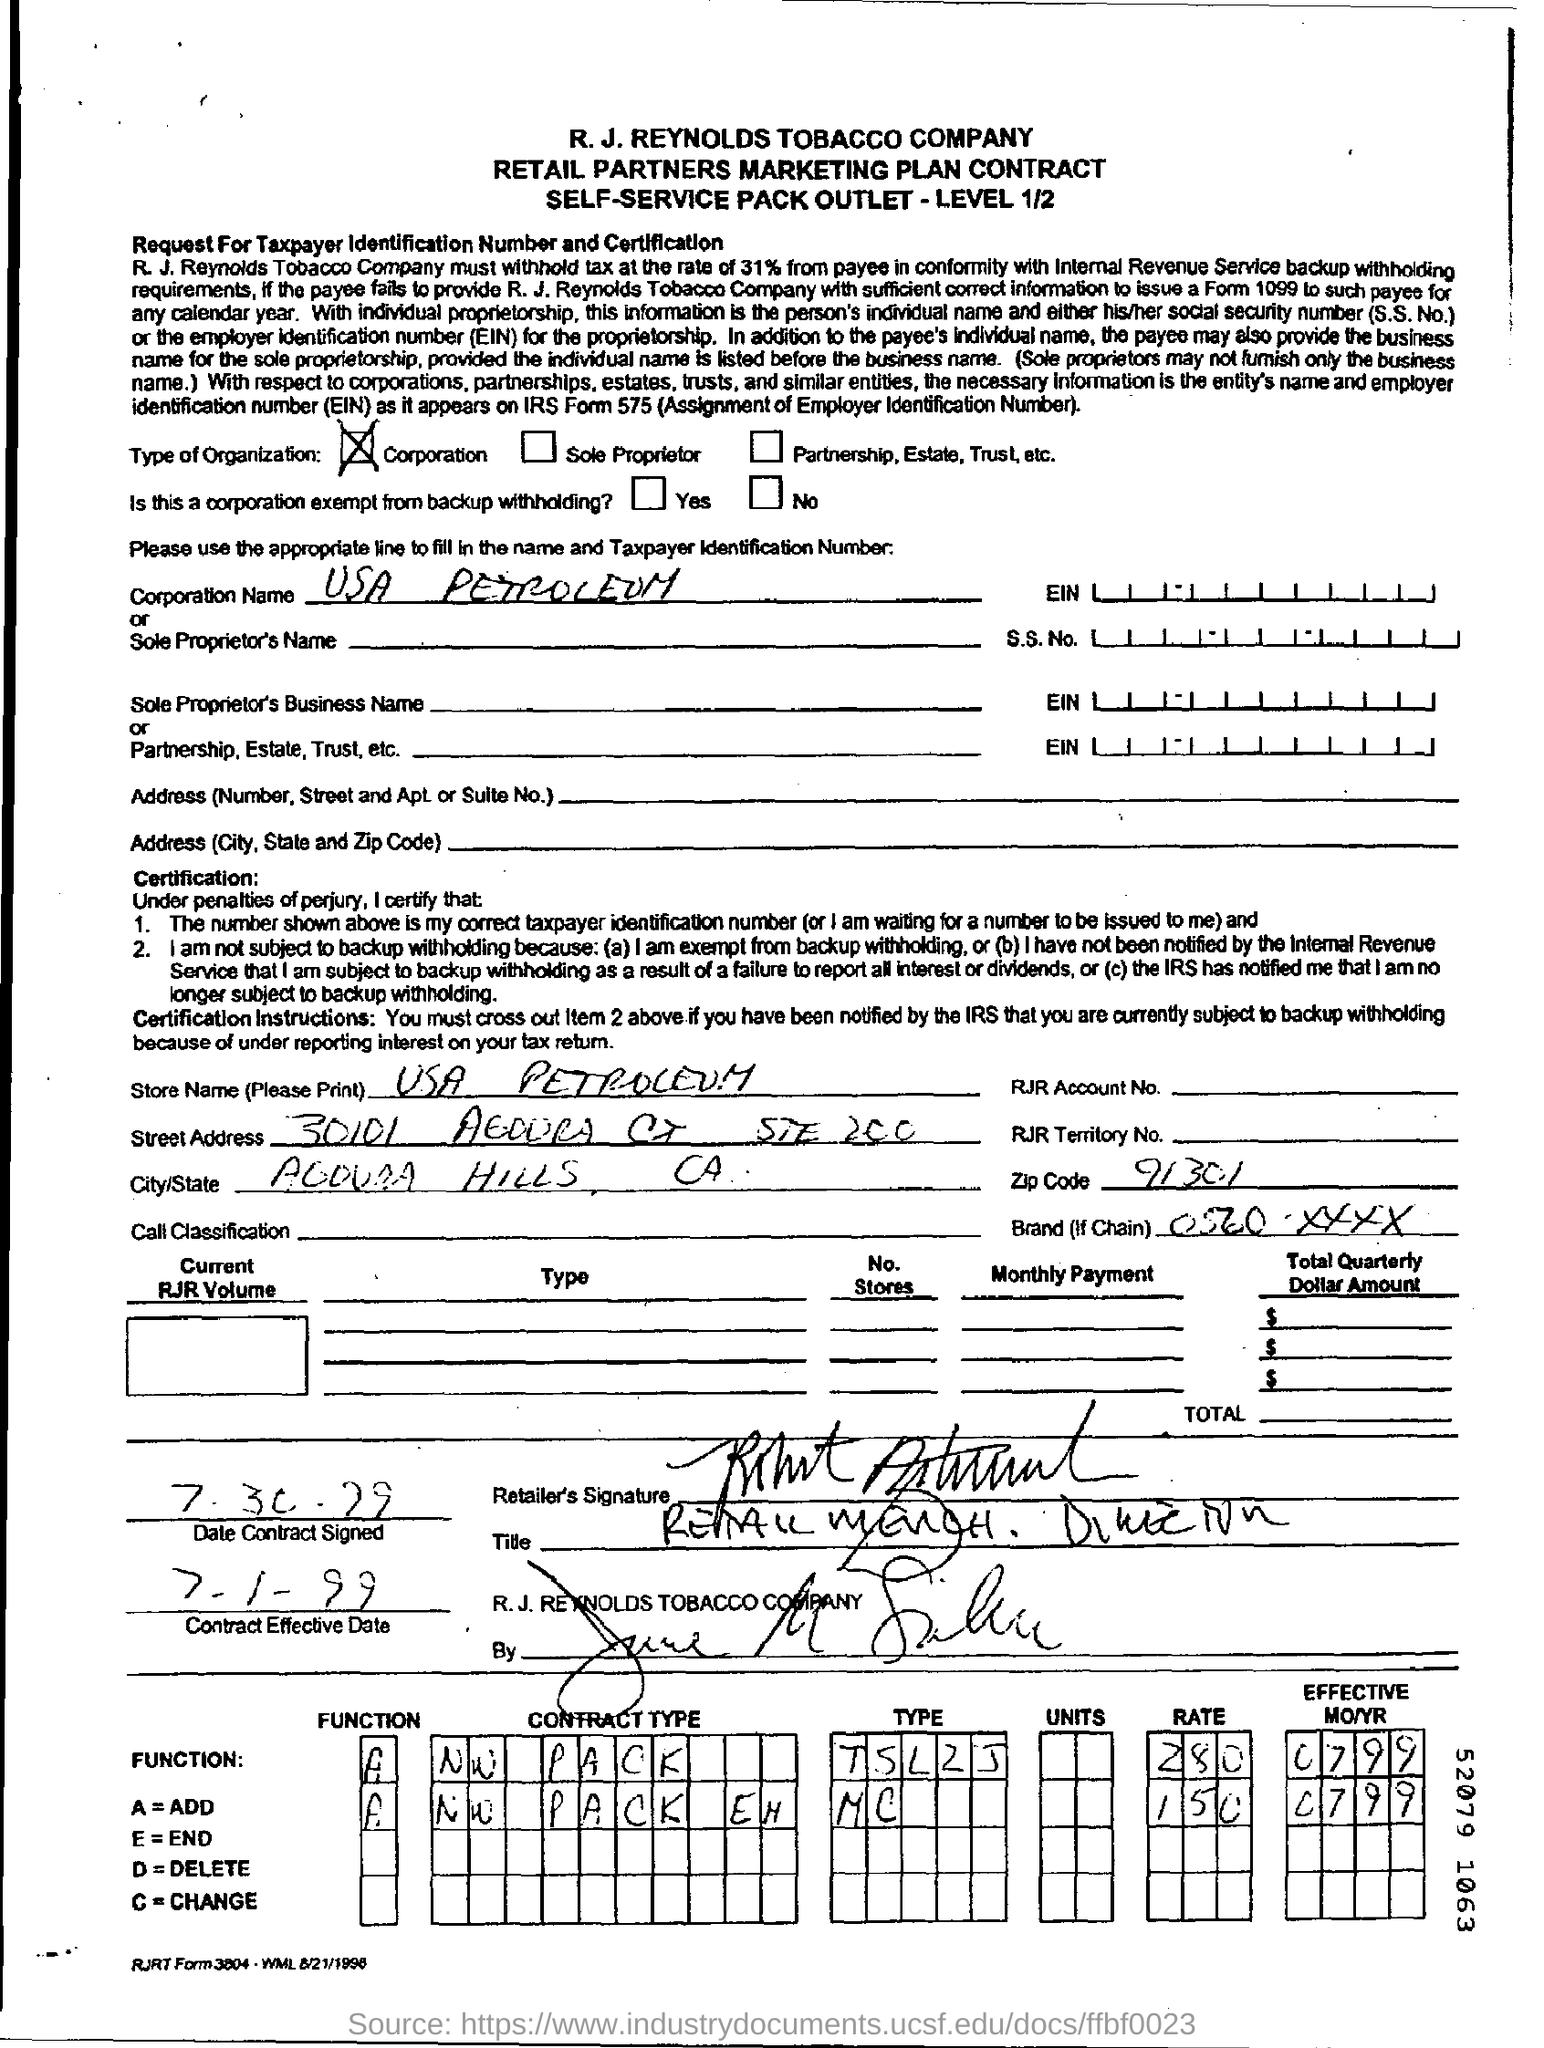Point out several critical features in this image. USA Petroleum is the corporation name. The organization is a corporation. The effective date of the contract is 7th January 1999. 